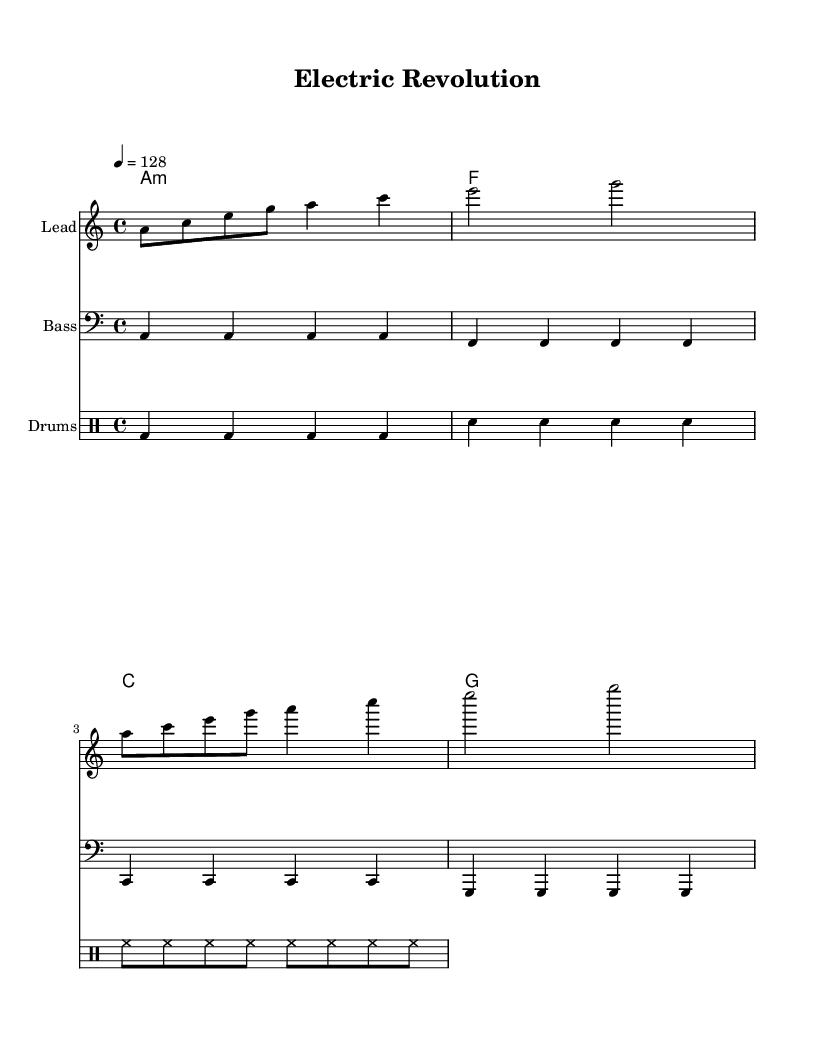What is the key signature of this music? The key signature is represented by the absence of sharps or flats at the beginning of the staff, which indicates it is in the key of A minor.
Answer: A minor What is the time signature of this music? The time signature is indicated at the start of the score as 4/4, which shows that there are four beats in each measure and the quarter note receives one beat.
Answer: 4/4 What is the tempo marking for this piece? The tempo marking specified in the score is 4 = 128, indicating that there are 128 beats per minute in the piece.
Answer: 128 How many measures are in the melody? The melody section consists of four measures, as indicated by the four sets of bar lines.
Answer: 4 What is the harmonic progression used in this piece? The harmonic progression is formed by the chords A minor, F, C, and G, which is a common progression in house music for creating uplifting anthems.
Answer: A minor, F, C, G What type of percussion is primarily featured in the drum section? The drum section shows the use of bass drum, snare drum, and hi-hat, which are essential components for the rhythmic foundation in house music.
Answer: Bass drum, snare drum, hi-hat Which part plays the lead melody? The lead melody is played by the 'Lead' staff, where the notes are indicated, demonstrating the melodic line that typically drives the emotion in the piece.
Answer: Lead 